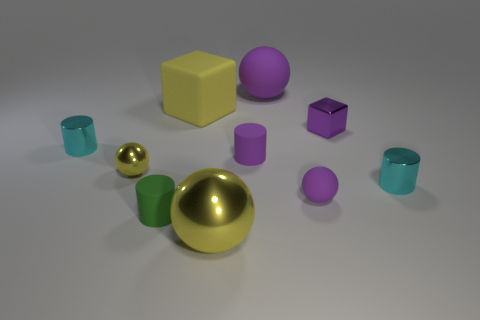Subtract all purple balls. How many were subtracted if there are1purple balls left? 1 Subtract all blue cylinders. How many purple spheres are left? 2 Subtract all small purple spheres. How many spheres are left? 3 Subtract 2 balls. How many balls are left? 2 Subtract all green cylinders. How many cylinders are left? 3 Subtract all spheres. How many objects are left? 6 Subtract 0 gray blocks. How many objects are left? 10 Subtract all brown spheres. Subtract all blue blocks. How many spheres are left? 4 Subtract all tiny green matte balls. Subtract all tiny matte balls. How many objects are left? 9 Add 9 small green matte cylinders. How many small green matte cylinders are left? 10 